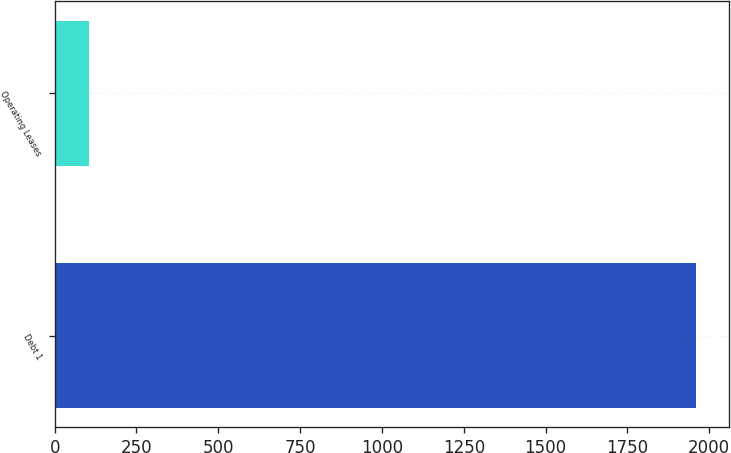<chart> <loc_0><loc_0><loc_500><loc_500><bar_chart><fcel>Debt 1<fcel>Operating Leases<nl><fcel>1961<fcel>106<nl></chart> 